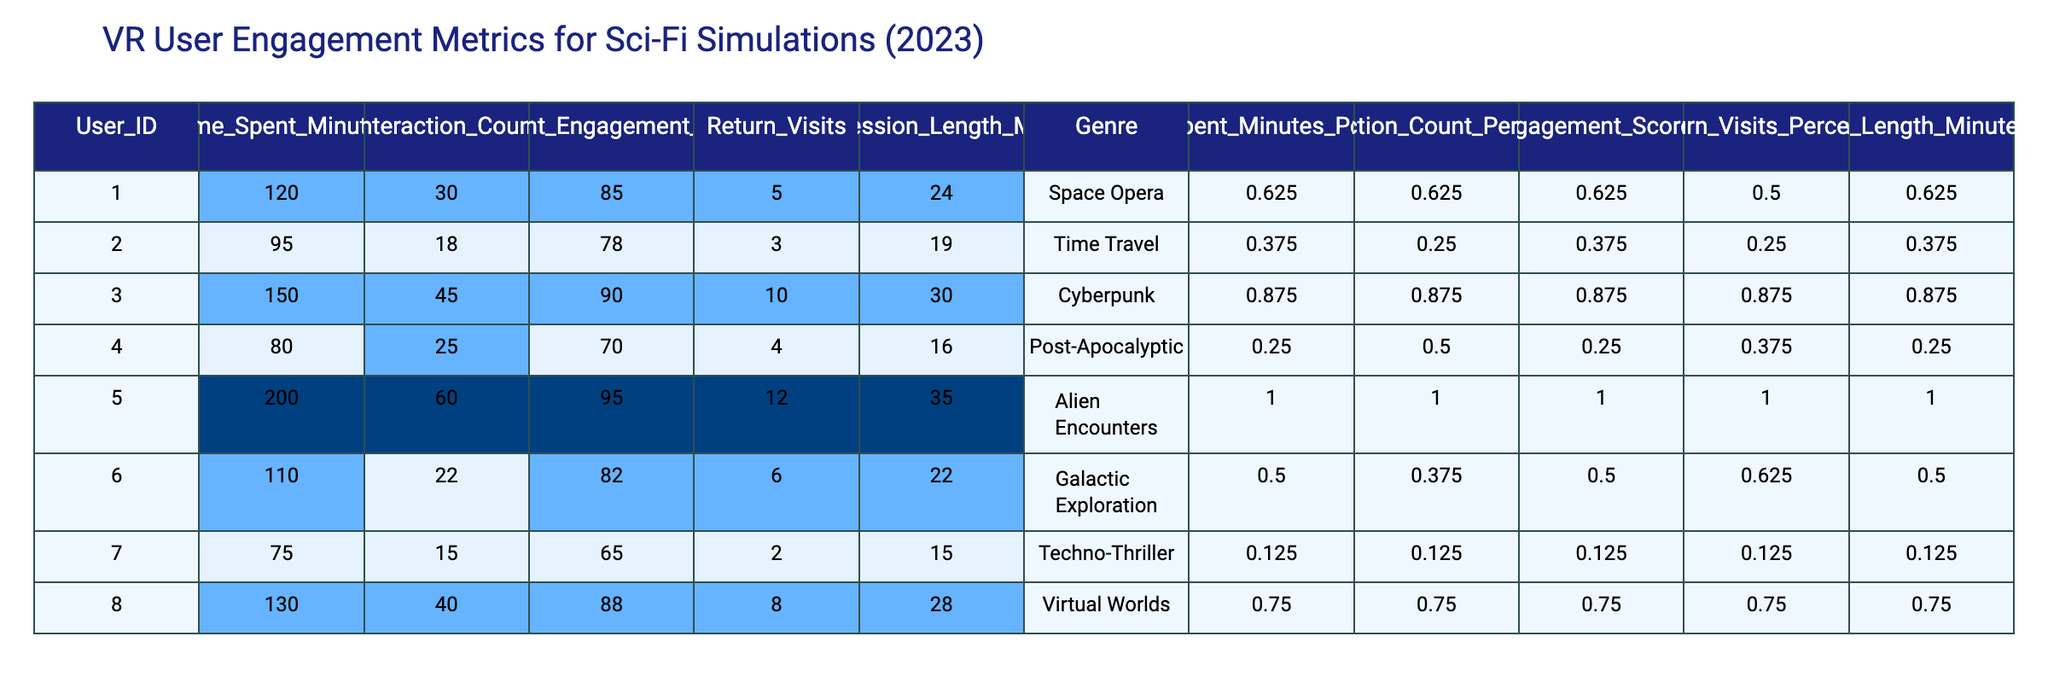What is the highest Content Engagement Score among the users? The Content Engagement Score is listed for each user. The highest score in the table is 95, which belongs to user 005.
Answer: 95 Which genre had the most return visits? The Return Visits column shows user counts for each genre. User 005 (Alien Encounters) has the highest return visits count of 12.
Answer: Alien Encounters What is the average time spent by users in the Time Travel genre? User 002 has the only entry for the Time Travel genre, which is 95 minutes. Thus, the average is also 95 minutes.
Answer: 95 Is the average session length greater for Cyberpunk compared to Space Opera? The Avg Session Length for Cyberpunk is 30 minutes, and for Space Opera, it is 24 minutes. Since 30 > 24, the answer is yes.
Answer: Yes How does the average Interaction Count compare between Alien Encounters and Post-Apocalyptic genres? User 005 (Alien Encounters) has an Interaction Count of 60, and user 004 (Post-Apocalyptic) has 25. The average for Alien Encounters is higher than for Post-Apocalyptic.
Answer: Alien Encounters is higher What is the total engagement score for all users? The engagement scores are added together: 85 + 78 + 90 + 70 + 95 + 82 + 65 + 88 = 678.
Answer: 678 Which genres have an average session length of less than 20 minutes? The data shows that the only genre with an average session length under 20 minutes is Techno-Thriller, which is 15 minutes.
Answer: Techno-Thriller What is the user with the least return visits, and what is their genre? User 007 has 2 return visits, which is the least recorded. Their genre is Techno-Thriller.
Answer: Techno-Thriller What genre has the highest average time spent? The average time spent for Alien Encounters is 200 minutes, which is the highest, compared to the others.
Answer: Alien Encounters Which user has the highest number of interactions and what is their engagement score? User 005 has the highest Interaction Count of 60 and their Content Engagement Score is 95.
Answer: User 005, 95 